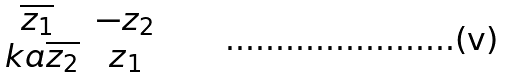Convert formula to latex. <formula><loc_0><loc_0><loc_500><loc_500>\begin{matrix} \overline { z _ { 1 } } & - z _ { 2 } \\ \ k a \overline { z _ { 2 } } & z _ { 1 } \end{matrix}</formula> 